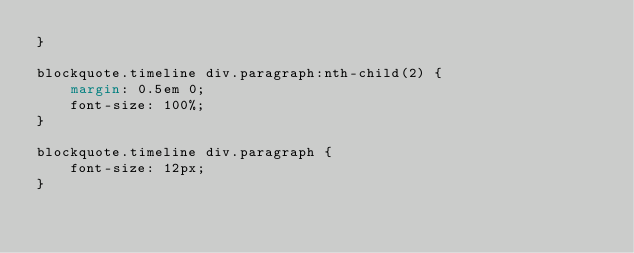<code> <loc_0><loc_0><loc_500><loc_500><_CSS_>}

blockquote.timeline div.paragraph:nth-child(2) {
    margin: 0.5em 0;
    font-size: 100%;
}

blockquote.timeline div.paragraph {
    font-size: 12px;
}
</code> 